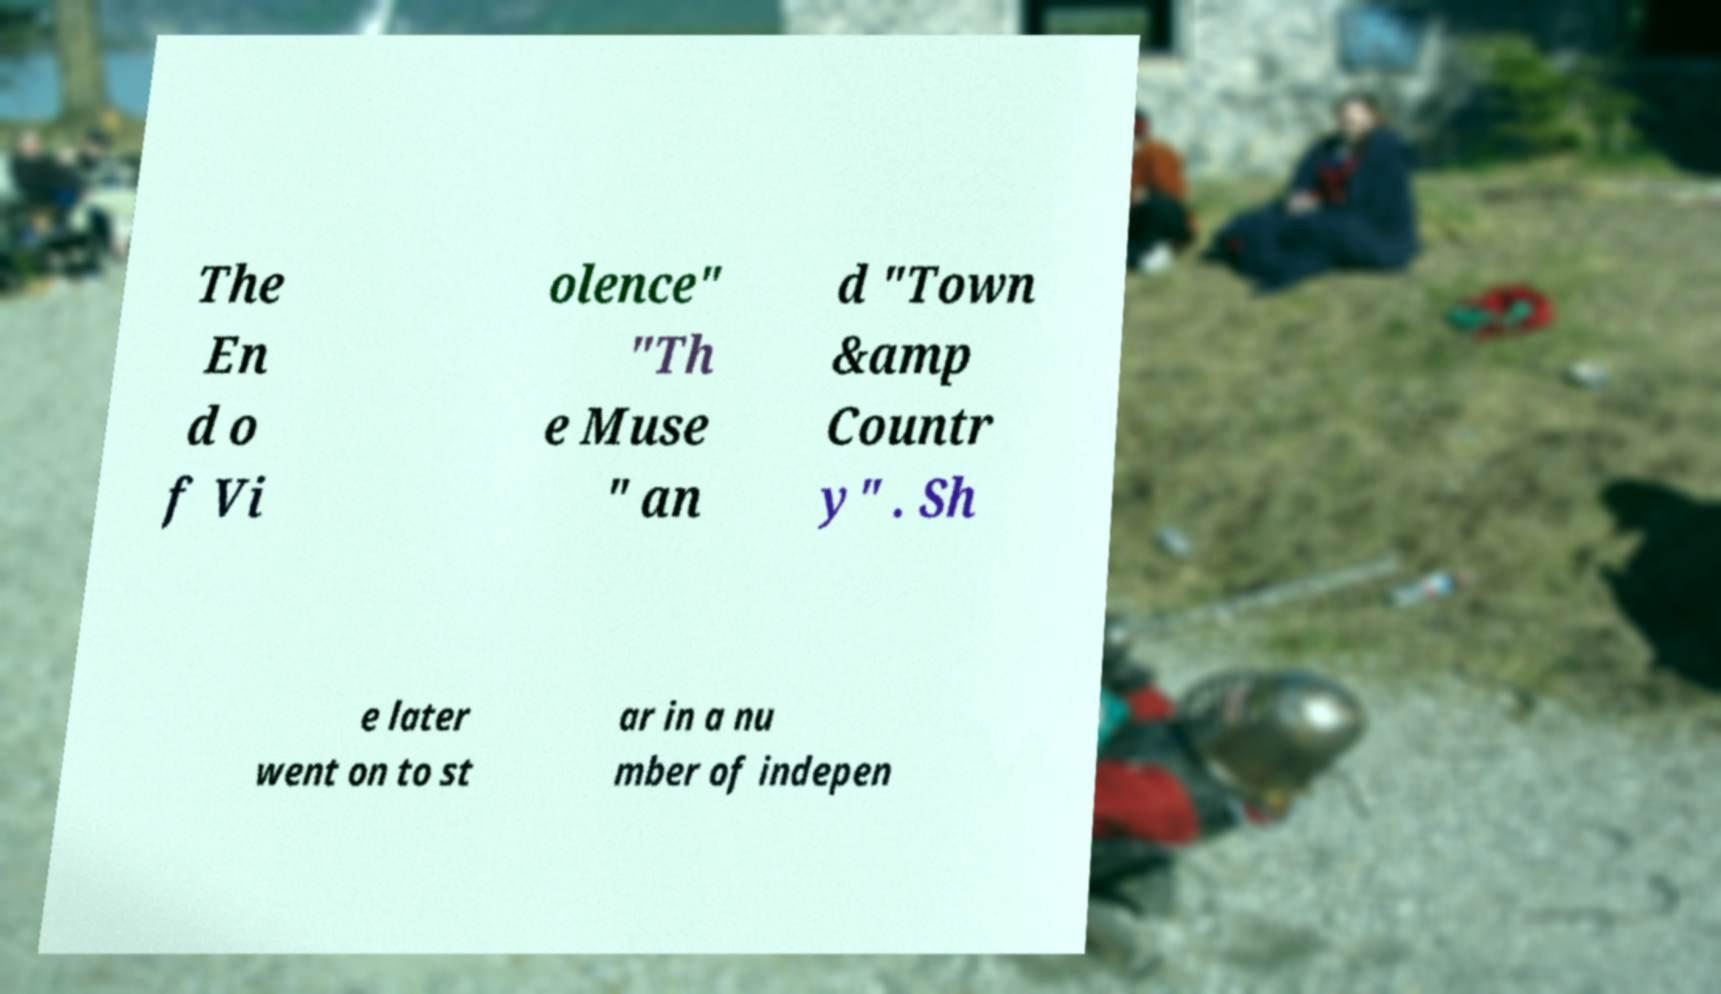What messages or text are displayed in this image? I need them in a readable, typed format. The En d o f Vi olence" "Th e Muse " an d "Town &amp Countr y" . Sh e later went on to st ar in a nu mber of indepen 